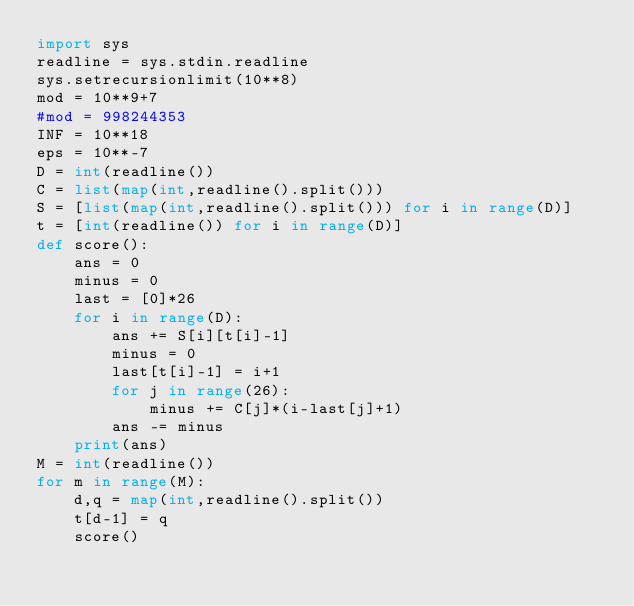<code> <loc_0><loc_0><loc_500><loc_500><_Python_>import sys
readline = sys.stdin.readline
sys.setrecursionlimit(10**8)
mod = 10**9+7
#mod = 998244353
INF = 10**18
eps = 10**-7
D = int(readline())
C = list(map(int,readline().split()))
S = [list(map(int,readline().split())) for i in range(D)]
t = [int(readline()) for i in range(D)]
def score():
    ans = 0
    minus = 0
    last = [0]*26
    for i in range(D):
        ans += S[i][t[i]-1]
        minus = 0
        last[t[i]-1] = i+1
        for j in range(26):
            minus += C[j]*(i-last[j]+1)
        ans -= minus
    print(ans)
M = int(readline())
for m in range(M):
    d,q = map(int,readline().split())
    t[d-1] = q
    score()


</code> 